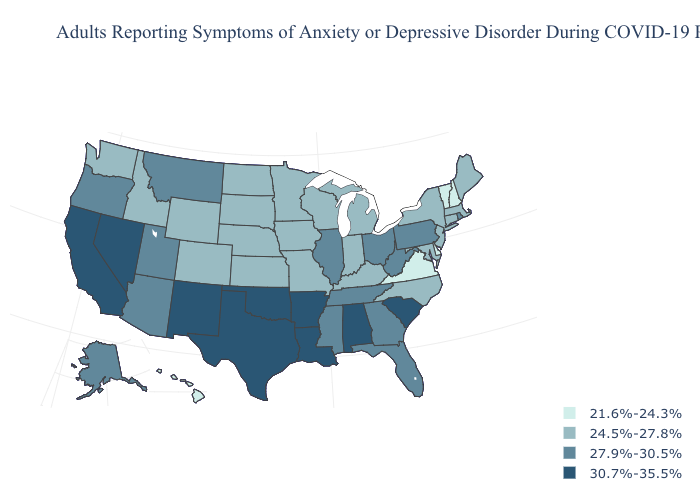Which states have the lowest value in the USA?
Write a very short answer. Delaware, Hawaii, New Hampshire, Vermont, Virginia. What is the lowest value in the USA?
Quick response, please. 21.6%-24.3%. Does the map have missing data?
Give a very brief answer. No. Does New York have the highest value in the Northeast?
Quick response, please. No. What is the value of Idaho?
Concise answer only. 24.5%-27.8%. What is the value of Arkansas?
Short answer required. 30.7%-35.5%. Does the first symbol in the legend represent the smallest category?
Write a very short answer. Yes. Name the states that have a value in the range 21.6%-24.3%?
Short answer required. Delaware, Hawaii, New Hampshire, Vermont, Virginia. Name the states that have a value in the range 21.6%-24.3%?
Give a very brief answer. Delaware, Hawaii, New Hampshire, Vermont, Virginia. Name the states that have a value in the range 27.9%-30.5%?
Quick response, please. Alaska, Arizona, Florida, Georgia, Illinois, Mississippi, Montana, Ohio, Oregon, Pennsylvania, Rhode Island, Tennessee, Utah, West Virginia. How many symbols are there in the legend?
Keep it brief. 4. What is the value of Oregon?
Write a very short answer. 27.9%-30.5%. Among the states that border Mississippi , does Tennessee have the highest value?
Write a very short answer. No. What is the value of Washington?
Give a very brief answer. 24.5%-27.8%. Does the map have missing data?
Answer briefly. No. 